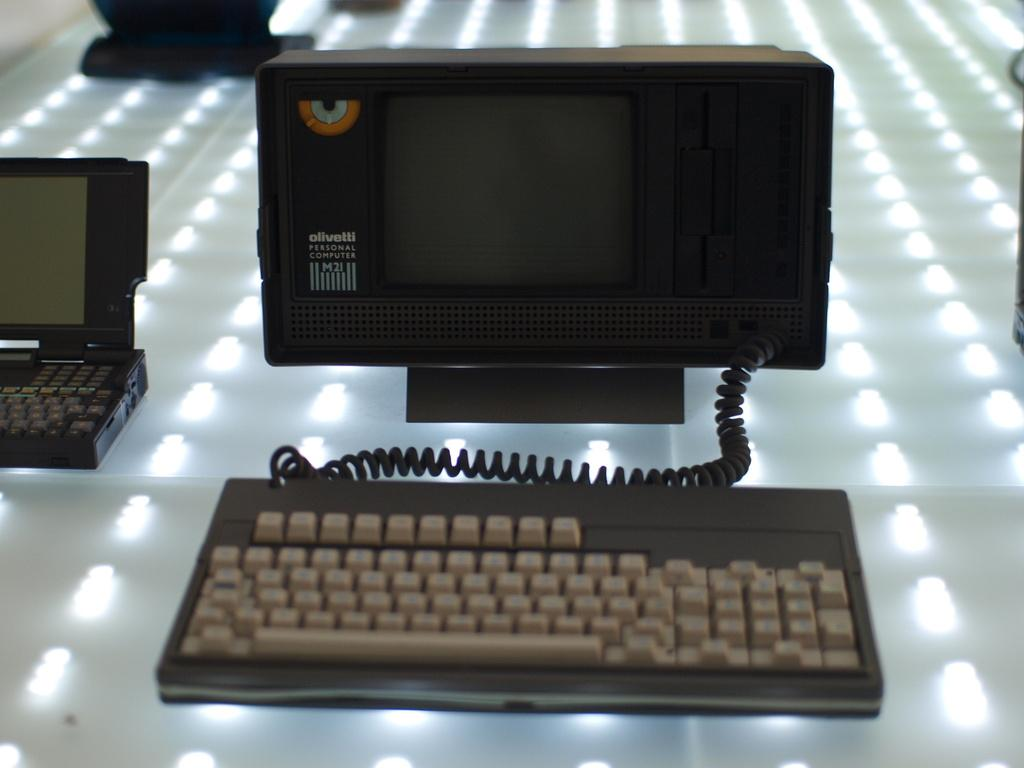<image>
Render a clear and concise summary of the photo. A olivetti personal computer with a keyboard is displayed on a lighted table. 